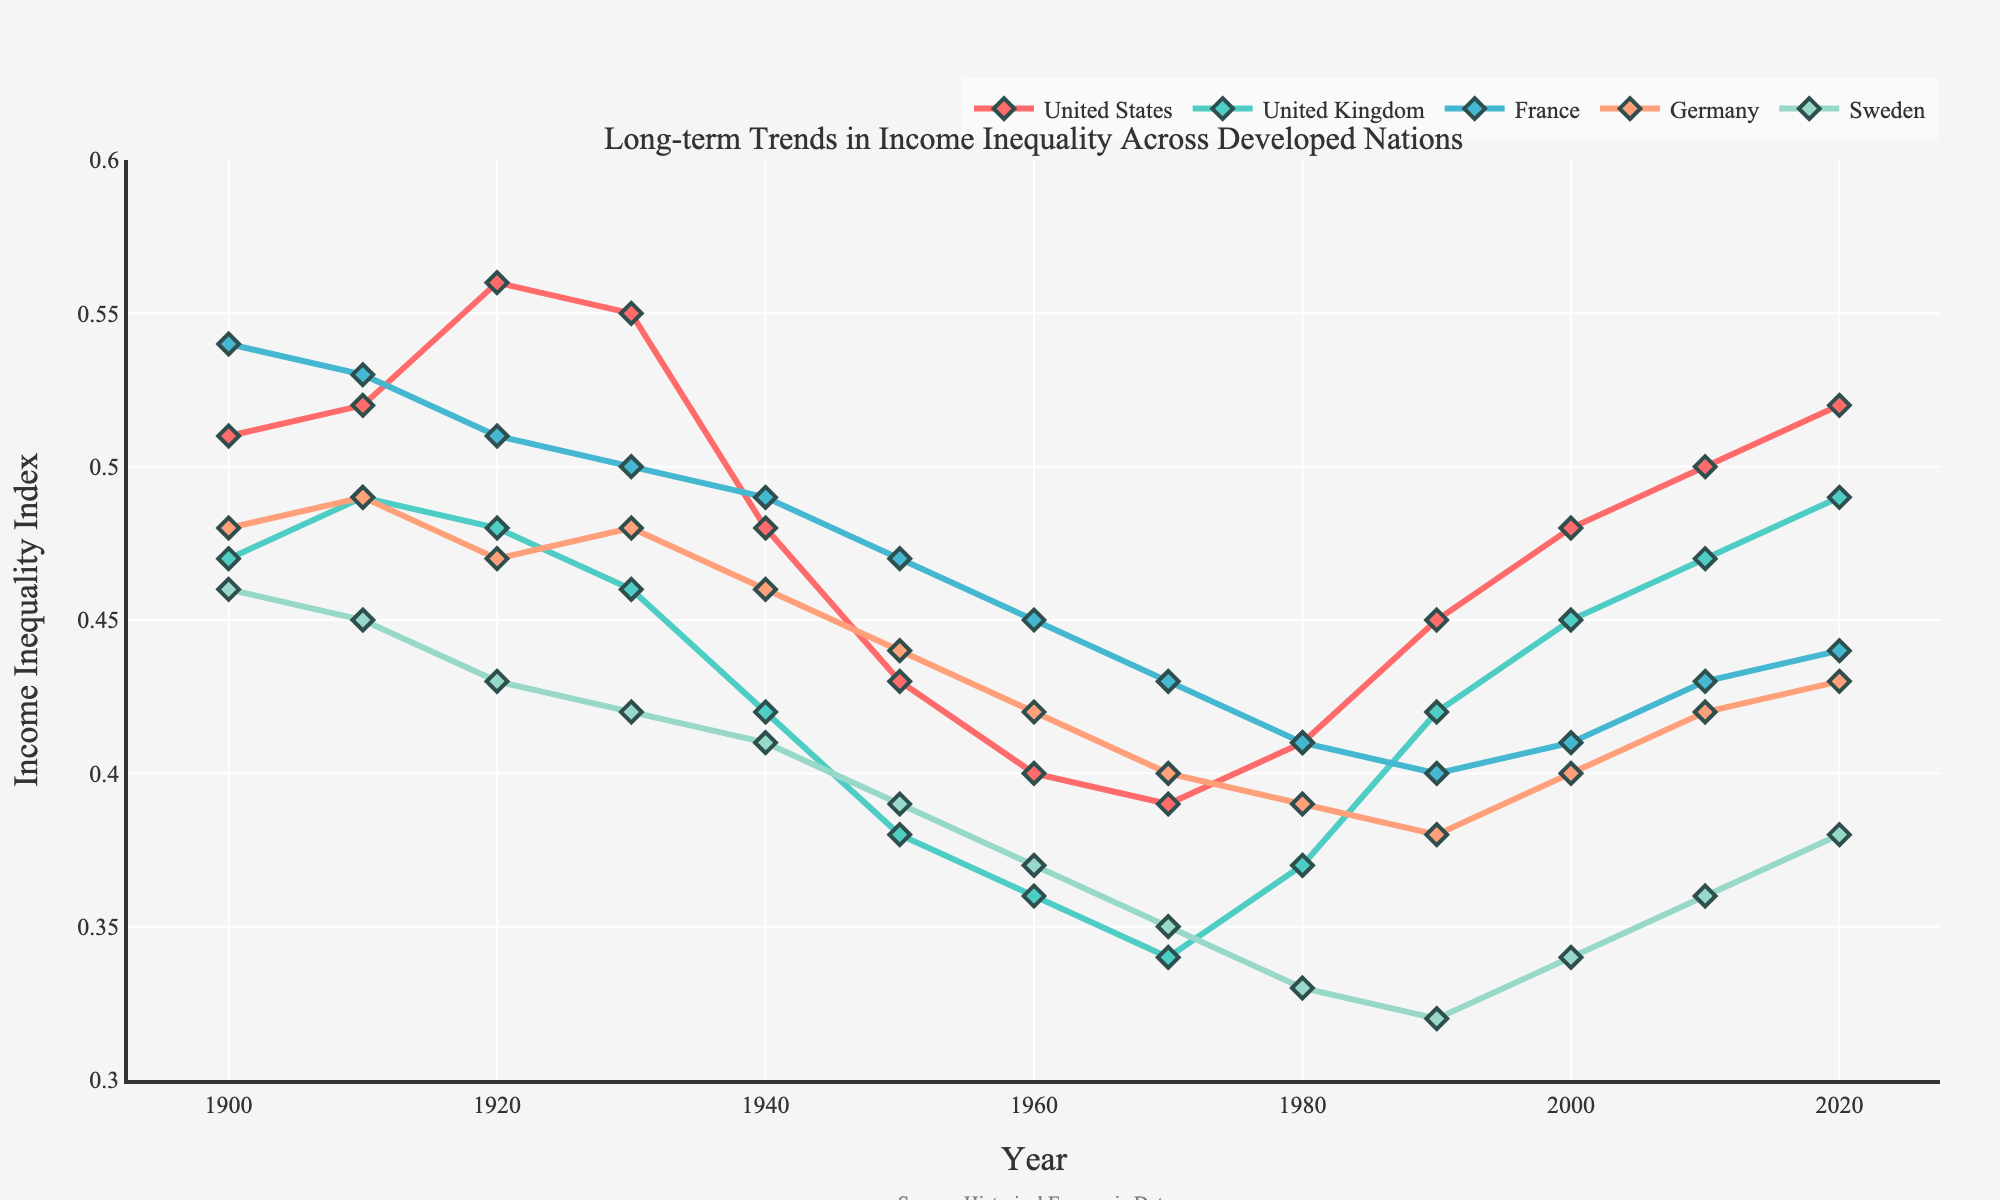Which country shows the highest income inequality index in 2020? To find this, look at the end year of 2020 on the x-axis and check which country marks the highest point on the y-axis. The United States has the highest value at 0.52.
Answer: United States Which country experienced the most significant decrease in income inequality from 1920 to 1950? Compare the income inequality values for each country in the years 1920 and 1950, and calculate the difference. France's income inequality decreased from 0.51 to 0.47, a drop of 0.04, the largest reduction among the countries.
Answer: France What is the trend in income inequality for Sweden from 1900 to 2020? To understand the trend, observe the line corresponding to Sweden over time. The line generally moves downward from 0.46 in 1900 to a low of 0.33 in 1980, then minor fluctuations but broadly increases to 0.38 by 2020.
Answer: Downward then upward Which two countries had nearly the same levels of income inequality around 1960? Look for closely spaced points in the year 1960 on the x-axis. The United Kingdom and Germany had values of 0.36 and 0.42, respectively, making them relatively close.
Answer: United Kingdom and Germany How has income inequality in the United States changed from 1900 to 2020? Track the United States' line from 1900 to 2020. It starts at 0.51, peaks around 1920-1930, drops notably to 0.39 in 1970, and then rises again to 0.52 by 2020.
Answer: Increased overall Which country's income inequality remained the lowest for much of the 20th century? Compare the lines across the countries, focusing on the majority of the 20th century. Sweden consistently has among the lowest values across many years.
Answer: Sweden From 1980 onwards, which country shows the most steady increase in income inequality? Observe the lines from the year 1980 onward. The United States shows a noticeable and steady increase from 0.41 to 0.52.
Answer: United States How does the income inequality in France in 2000 compare to that in 1980? Refer to France's data points for 1980 and 2000 on the x-axis. In 1980, the value was 0.41, while in 2000 it rose slightly to 0.41.
Answer: Same Between 1930 and 1950, which country saw the sharpest decline in income inequality? Analyze the values for each country between 1930 and 1950. The United States shows a decline from 0.55 to 0.43, the most significant decrease during this period.
Answer: United States By the year 2000, which country had the largest increase in income inequality compared to its lowest point throughout the century? Identify each country's lowest point and compare it to the value in 2000. The United States had its lowest at 0.39 in 1970 and increased to 0.48 by 2000, representing a notable rise.
Answer: United States 